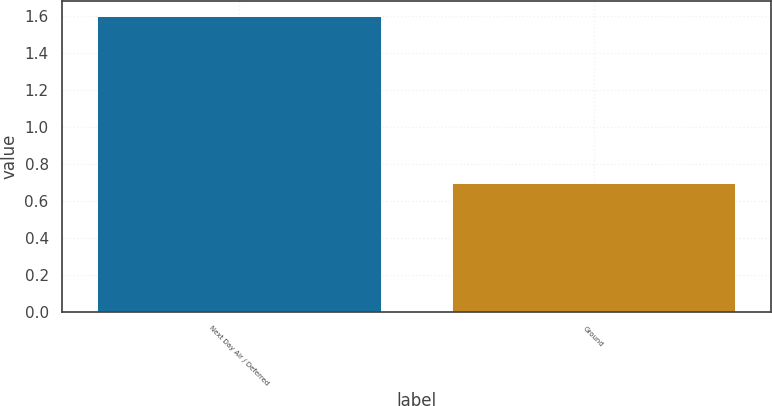Convert chart to OTSL. <chart><loc_0><loc_0><loc_500><loc_500><bar_chart><fcel>Next Day Air / Deferred<fcel>Ground<nl><fcel>1.6<fcel>0.7<nl></chart> 